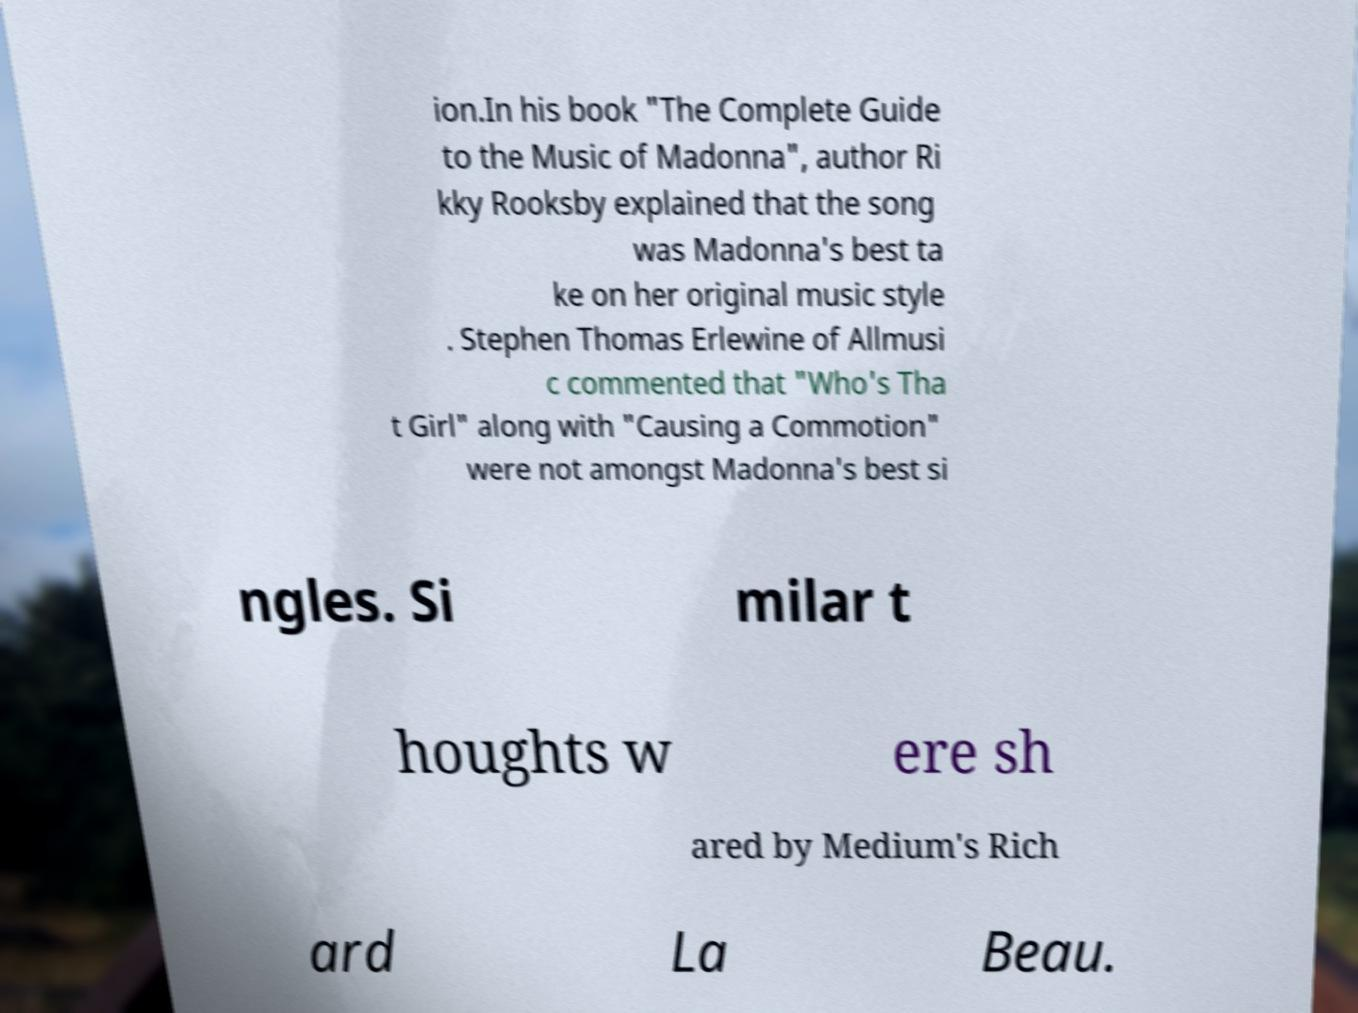Can you read and provide the text displayed in the image?This photo seems to have some interesting text. Can you extract and type it out for me? ion.In his book "The Complete Guide to the Music of Madonna", author Ri kky Rooksby explained that the song was Madonna's best ta ke on her original music style . Stephen Thomas Erlewine of Allmusi c commented that "Who's Tha t Girl" along with "Causing a Commotion" were not amongst Madonna's best si ngles. Si milar t houghts w ere sh ared by Medium's Rich ard La Beau. 